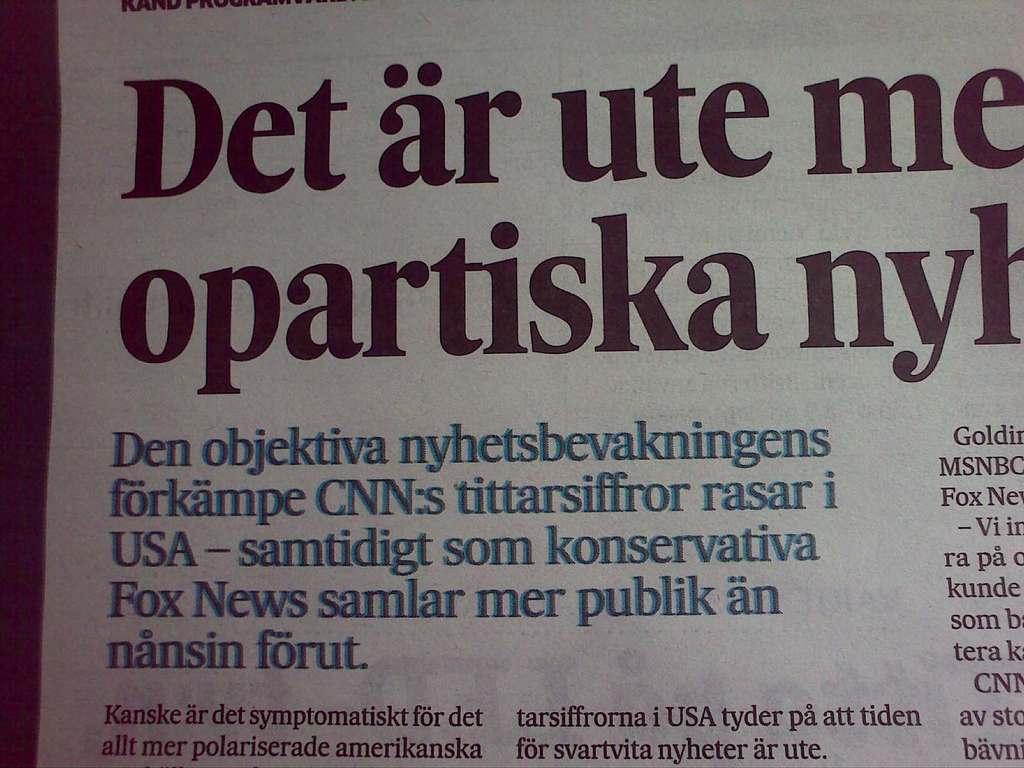What news channel is mentioned?
Ensure brevity in your answer.  Cnn. What country is mentioned in this article?
Keep it short and to the point. Usa. 